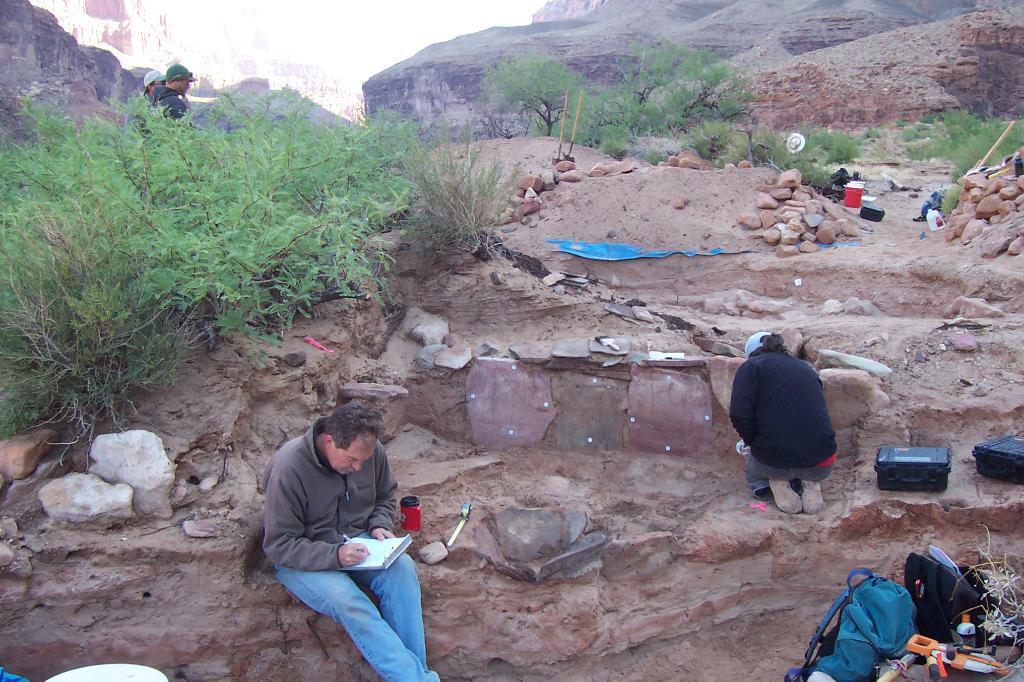In one or two sentences, can you explain what this image depicts? In this picture I can see a man writing on a book at the bottom, on the right side I can see a person, in the middle there are trees and stones. On the left side there are two persons, in the background I can see the hills, in the bottom right hand side I can see few bags and other things. 